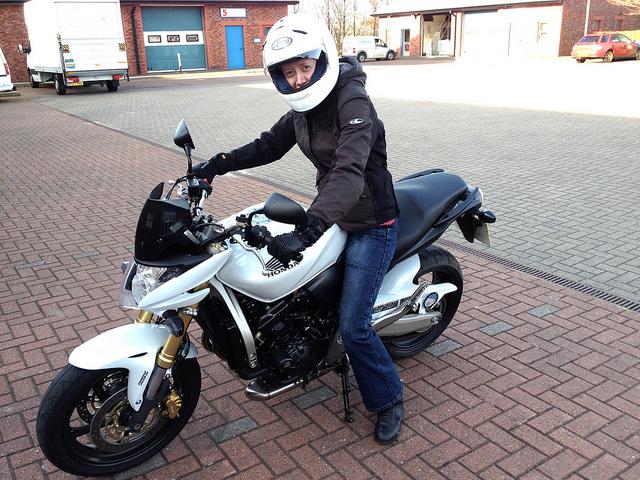What color is the motorbike?
Give a very brief answer. White. Would this bike fall over if the person got off?
Short answer required. No. Is the bike in motion?
Be succinct. No. 